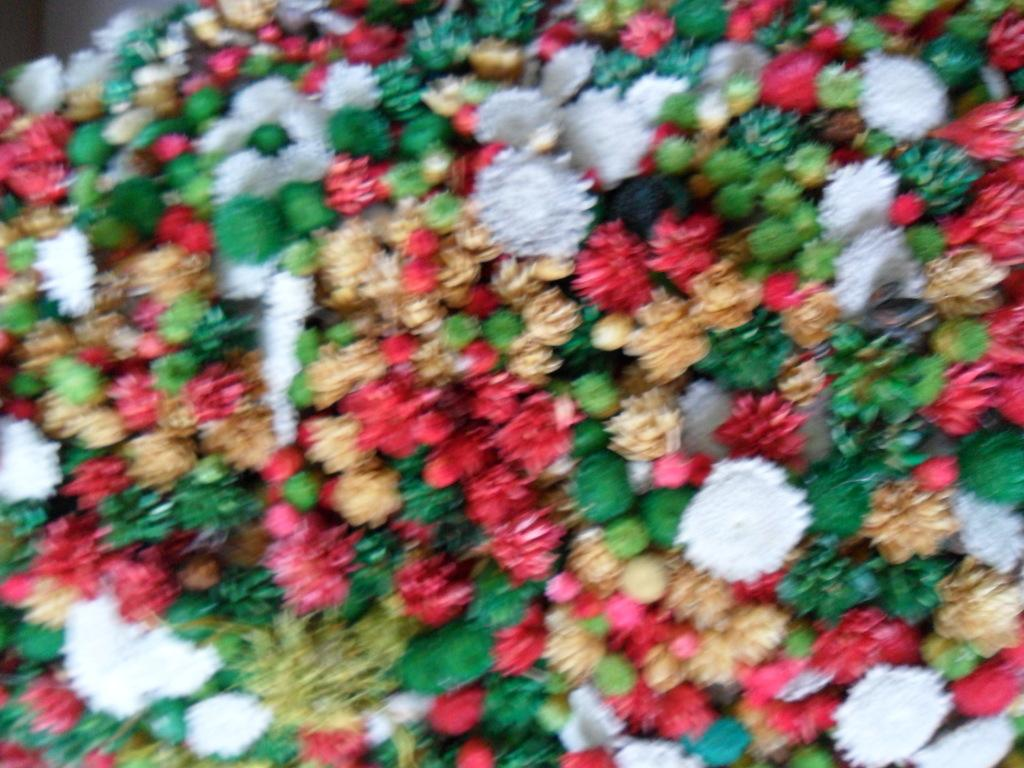What types of plants are visible in the image? There are flowers of different colors in the image. Can you describe the variety of colors present in the flowers? The flowers have different colors, but the specific shades are not mentioned in the facts. What might be the purpose of having flowers of different colors in the image? The purpose of having flowers of different colors in the image could be for aesthetic reasons or to represent a diverse garden or bouquet. What type of ship can be seen sailing through the flowers in the image? There is no ship present in the image; it only features flowers of different colors. 